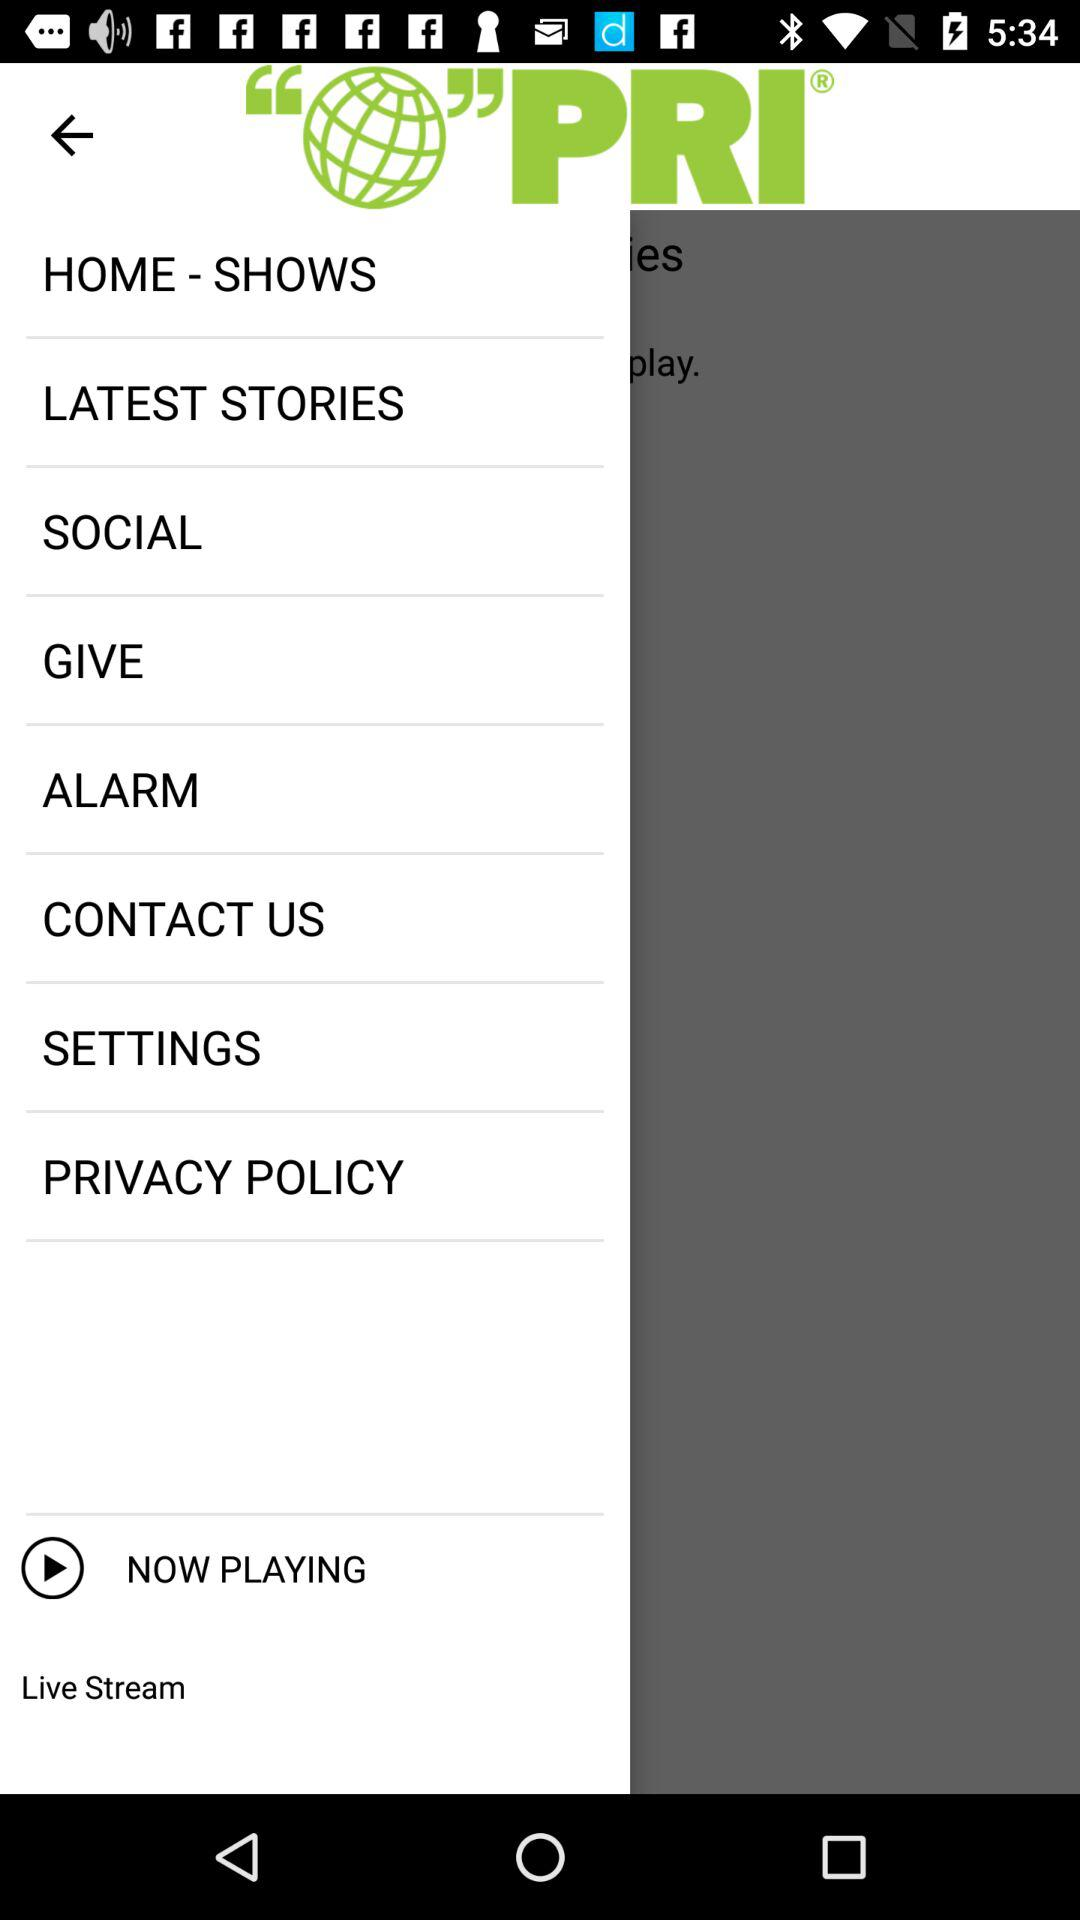Which days of the week are selected for the alarm?
When the provided information is insufficient, respond with <no answer>. <no answer> 